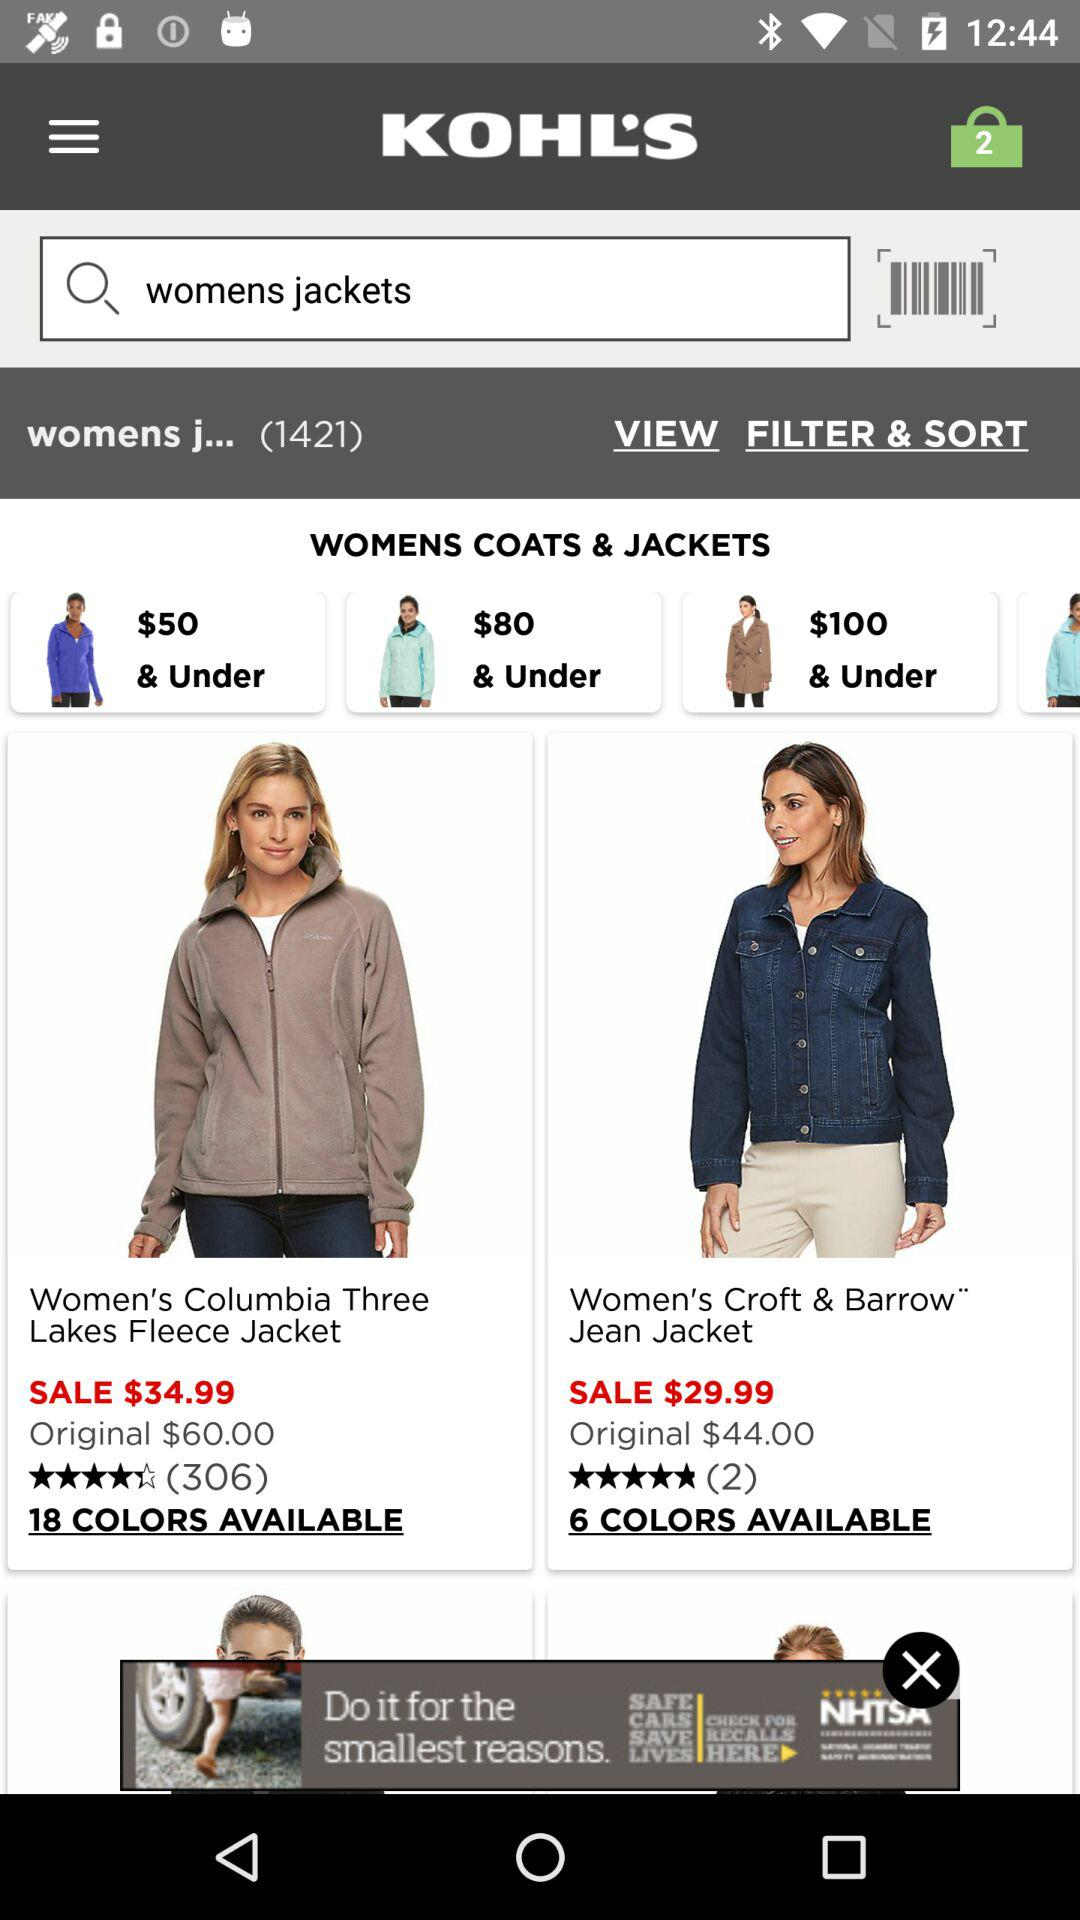What is the original price of the women's Croft and Barrow jean jacket? The original price is $44. 